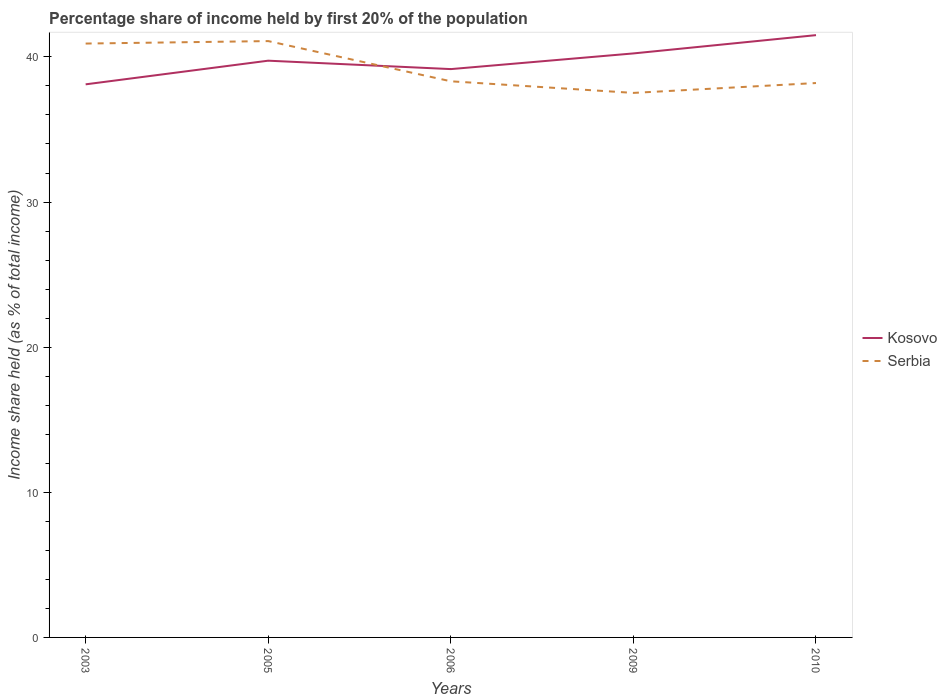How many different coloured lines are there?
Your response must be concise. 2. Does the line corresponding to Kosovo intersect with the line corresponding to Serbia?
Provide a short and direct response. Yes. Is the number of lines equal to the number of legend labels?
Offer a very short reply. Yes. Across all years, what is the maximum share of income held by first 20% of the population in Serbia?
Your answer should be compact. 37.52. What is the total share of income held by first 20% of the population in Serbia in the graph?
Provide a short and direct response. 0.8. What is the difference between the highest and the second highest share of income held by first 20% of the population in Kosovo?
Provide a succinct answer. 3.39. How many lines are there?
Provide a succinct answer. 2. How many years are there in the graph?
Offer a terse response. 5. Does the graph contain grids?
Make the answer very short. No. Where does the legend appear in the graph?
Give a very brief answer. Center right. How many legend labels are there?
Provide a short and direct response. 2. What is the title of the graph?
Your answer should be very brief. Percentage share of income held by first 20% of the population. Does "Belize" appear as one of the legend labels in the graph?
Make the answer very short. No. What is the label or title of the X-axis?
Keep it short and to the point. Years. What is the label or title of the Y-axis?
Your answer should be compact. Income share held (as % of total income). What is the Income share held (as % of total income) of Kosovo in 2003?
Your response must be concise. 38.11. What is the Income share held (as % of total income) in Serbia in 2003?
Provide a short and direct response. 40.92. What is the Income share held (as % of total income) in Kosovo in 2005?
Offer a very short reply. 39.74. What is the Income share held (as % of total income) of Serbia in 2005?
Give a very brief answer. 41.09. What is the Income share held (as % of total income) in Kosovo in 2006?
Provide a succinct answer. 39.16. What is the Income share held (as % of total income) in Serbia in 2006?
Provide a succinct answer. 38.32. What is the Income share held (as % of total income) of Kosovo in 2009?
Provide a succinct answer. 40.24. What is the Income share held (as % of total income) of Serbia in 2009?
Offer a very short reply. 37.52. What is the Income share held (as % of total income) of Kosovo in 2010?
Provide a short and direct response. 41.5. What is the Income share held (as % of total income) of Serbia in 2010?
Give a very brief answer. 38.2. Across all years, what is the maximum Income share held (as % of total income) in Kosovo?
Provide a succinct answer. 41.5. Across all years, what is the maximum Income share held (as % of total income) in Serbia?
Ensure brevity in your answer.  41.09. Across all years, what is the minimum Income share held (as % of total income) of Kosovo?
Keep it short and to the point. 38.11. Across all years, what is the minimum Income share held (as % of total income) in Serbia?
Give a very brief answer. 37.52. What is the total Income share held (as % of total income) in Kosovo in the graph?
Your response must be concise. 198.75. What is the total Income share held (as % of total income) of Serbia in the graph?
Provide a short and direct response. 196.05. What is the difference between the Income share held (as % of total income) of Kosovo in 2003 and that in 2005?
Your response must be concise. -1.63. What is the difference between the Income share held (as % of total income) in Serbia in 2003 and that in 2005?
Offer a terse response. -0.17. What is the difference between the Income share held (as % of total income) in Kosovo in 2003 and that in 2006?
Provide a short and direct response. -1.05. What is the difference between the Income share held (as % of total income) in Serbia in 2003 and that in 2006?
Provide a succinct answer. 2.6. What is the difference between the Income share held (as % of total income) in Kosovo in 2003 and that in 2009?
Offer a terse response. -2.13. What is the difference between the Income share held (as % of total income) in Kosovo in 2003 and that in 2010?
Provide a short and direct response. -3.39. What is the difference between the Income share held (as % of total income) of Serbia in 2003 and that in 2010?
Provide a short and direct response. 2.72. What is the difference between the Income share held (as % of total income) in Kosovo in 2005 and that in 2006?
Keep it short and to the point. 0.58. What is the difference between the Income share held (as % of total income) of Serbia in 2005 and that in 2006?
Keep it short and to the point. 2.77. What is the difference between the Income share held (as % of total income) in Serbia in 2005 and that in 2009?
Offer a very short reply. 3.57. What is the difference between the Income share held (as % of total income) of Kosovo in 2005 and that in 2010?
Keep it short and to the point. -1.76. What is the difference between the Income share held (as % of total income) of Serbia in 2005 and that in 2010?
Your answer should be very brief. 2.89. What is the difference between the Income share held (as % of total income) in Kosovo in 2006 and that in 2009?
Offer a very short reply. -1.08. What is the difference between the Income share held (as % of total income) in Kosovo in 2006 and that in 2010?
Offer a very short reply. -2.34. What is the difference between the Income share held (as % of total income) in Serbia in 2006 and that in 2010?
Give a very brief answer. 0.12. What is the difference between the Income share held (as % of total income) in Kosovo in 2009 and that in 2010?
Your response must be concise. -1.26. What is the difference between the Income share held (as % of total income) in Serbia in 2009 and that in 2010?
Give a very brief answer. -0.68. What is the difference between the Income share held (as % of total income) in Kosovo in 2003 and the Income share held (as % of total income) in Serbia in 2005?
Offer a very short reply. -2.98. What is the difference between the Income share held (as % of total income) of Kosovo in 2003 and the Income share held (as % of total income) of Serbia in 2006?
Offer a terse response. -0.21. What is the difference between the Income share held (as % of total income) in Kosovo in 2003 and the Income share held (as % of total income) in Serbia in 2009?
Give a very brief answer. 0.59. What is the difference between the Income share held (as % of total income) in Kosovo in 2003 and the Income share held (as % of total income) in Serbia in 2010?
Offer a terse response. -0.09. What is the difference between the Income share held (as % of total income) of Kosovo in 2005 and the Income share held (as % of total income) of Serbia in 2006?
Your response must be concise. 1.42. What is the difference between the Income share held (as % of total income) of Kosovo in 2005 and the Income share held (as % of total income) of Serbia in 2009?
Your answer should be compact. 2.22. What is the difference between the Income share held (as % of total income) in Kosovo in 2005 and the Income share held (as % of total income) in Serbia in 2010?
Offer a very short reply. 1.54. What is the difference between the Income share held (as % of total income) in Kosovo in 2006 and the Income share held (as % of total income) in Serbia in 2009?
Your response must be concise. 1.64. What is the difference between the Income share held (as % of total income) of Kosovo in 2009 and the Income share held (as % of total income) of Serbia in 2010?
Your response must be concise. 2.04. What is the average Income share held (as % of total income) of Kosovo per year?
Provide a short and direct response. 39.75. What is the average Income share held (as % of total income) of Serbia per year?
Provide a succinct answer. 39.21. In the year 2003, what is the difference between the Income share held (as % of total income) of Kosovo and Income share held (as % of total income) of Serbia?
Your answer should be very brief. -2.81. In the year 2005, what is the difference between the Income share held (as % of total income) of Kosovo and Income share held (as % of total income) of Serbia?
Make the answer very short. -1.35. In the year 2006, what is the difference between the Income share held (as % of total income) in Kosovo and Income share held (as % of total income) in Serbia?
Provide a short and direct response. 0.84. In the year 2009, what is the difference between the Income share held (as % of total income) of Kosovo and Income share held (as % of total income) of Serbia?
Offer a terse response. 2.72. In the year 2010, what is the difference between the Income share held (as % of total income) of Kosovo and Income share held (as % of total income) of Serbia?
Offer a very short reply. 3.3. What is the ratio of the Income share held (as % of total income) in Serbia in 2003 to that in 2005?
Your response must be concise. 1. What is the ratio of the Income share held (as % of total income) of Kosovo in 2003 to that in 2006?
Give a very brief answer. 0.97. What is the ratio of the Income share held (as % of total income) in Serbia in 2003 to that in 2006?
Ensure brevity in your answer.  1.07. What is the ratio of the Income share held (as % of total income) of Kosovo in 2003 to that in 2009?
Give a very brief answer. 0.95. What is the ratio of the Income share held (as % of total income) in Serbia in 2003 to that in 2009?
Make the answer very short. 1.09. What is the ratio of the Income share held (as % of total income) in Kosovo in 2003 to that in 2010?
Your response must be concise. 0.92. What is the ratio of the Income share held (as % of total income) in Serbia in 2003 to that in 2010?
Provide a succinct answer. 1.07. What is the ratio of the Income share held (as % of total income) in Kosovo in 2005 to that in 2006?
Your answer should be very brief. 1.01. What is the ratio of the Income share held (as % of total income) of Serbia in 2005 to that in 2006?
Offer a very short reply. 1.07. What is the ratio of the Income share held (as % of total income) of Kosovo in 2005 to that in 2009?
Provide a short and direct response. 0.99. What is the ratio of the Income share held (as % of total income) in Serbia in 2005 to that in 2009?
Offer a terse response. 1.1. What is the ratio of the Income share held (as % of total income) in Kosovo in 2005 to that in 2010?
Give a very brief answer. 0.96. What is the ratio of the Income share held (as % of total income) of Serbia in 2005 to that in 2010?
Your answer should be very brief. 1.08. What is the ratio of the Income share held (as % of total income) in Kosovo in 2006 to that in 2009?
Give a very brief answer. 0.97. What is the ratio of the Income share held (as % of total income) of Serbia in 2006 to that in 2009?
Your answer should be very brief. 1.02. What is the ratio of the Income share held (as % of total income) in Kosovo in 2006 to that in 2010?
Provide a succinct answer. 0.94. What is the ratio of the Income share held (as % of total income) in Serbia in 2006 to that in 2010?
Your response must be concise. 1. What is the ratio of the Income share held (as % of total income) of Kosovo in 2009 to that in 2010?
Keep it short and to the point. 0.97. What is the ratio of the Income share held (as % of total income) of Serbia in 2009 to that in 2010?
Make the answer very short. 0.98. What is the difference between the highest and the second highest Income share held (as % of total income) in Kosovo?
Provide a short and direct response. 1.26. What is the difference between the highest and the second highest Income share held (as % of total income) in Serbia?
Offer a very short reply. 0.17. What is the difference between the highest and the lowest Income share held (as % of total income) of Kosovo?
Your response must be concise. 3.39. What is the difference between the highest and the lowest Income share held (as % of total income) in Serbia?
Your response must be concise. 3.57. 